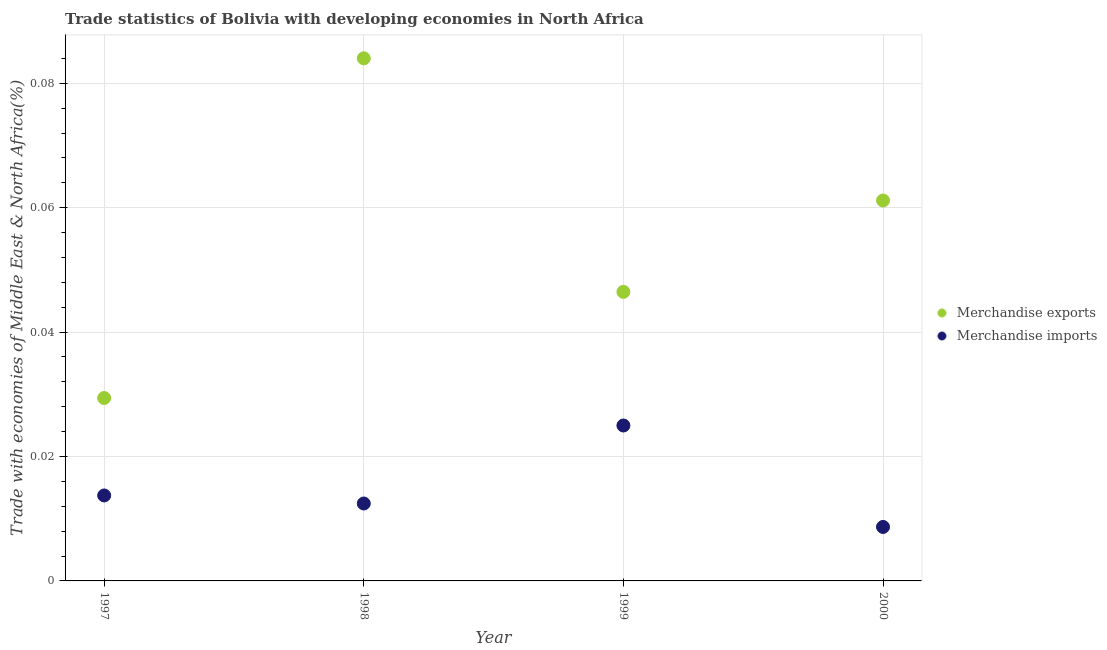How many different coloured dotlines are there?
Provide a succinct answer. 2. Is the number of dotlines equal to the number of legend labels?
Your answer should be very brief. Yes. What is the merchandise exports in 2000?
Ensure brevity in your answer.  0.06. Across all years, what is the maximum merchandise imports?
Your response must be concise. 0.02. Across all years, what is the minimum merchandise imports?
Your response must be concise. 0.01. What is the total merchandise exports in the graph?
Ensure brevity in your answer.  0.22. What is the difference between the merchandise imports in 1999 and that in 2000?
Your response must be concise. 0.02. What is the difference between the merchandise exports in 1997 and the merchandise imports in 2000?
Your answer should be compact. 0.02. What is the average merchandise exports per year?
Provide a short and direct response. 0.06. In the year 1997, what is the difference between the merchandise imports and merchandise exports?
Give a very brief answer. -0.02. What is the ratio of the merchandise exports in 1997 to that in 1998?
Provide a short and direct response. 0.35. Is the merchandise imports in 1997 less than that in 2000?
Give a very brief answer. No. What is the difference between the highest and the second highest merchandise exports?
Your response must be concise. 0.02. What is the difference between the highest and the lowest merchandise exports?
Provide a succinct answer. 0.05. In how many years, is the merchandise exports greater than the average merchandise exports taken over all years?
Make the answer very short. 2. Is the sum of the merchandise exports in 1999 and 2000 greater than the maximum merchandise imports across all years?
Your answer should be very brief. Yes. Is the merchandise exports strictly less than the merchandise imports over the years?
Ensure brevity in your answer.  No. How many dotlines are there?
Provide a short and direct response. 2. How many years are there in the graph?
Provide a short and direct response. 4. Are the values on the major ticks of Y-axis written in scientific E-notation?
Your answer should be very brief. No. Does the graph contain any zero values?
Your response must be concise. No. Does the graph contain grids?
Provide a short and direct response. Yes. Where does the legend appear in the graph?
Ensure brevity in your answer.  Center right. How many legend labels are there?
Provide a succinct answer. 2. How are the legend labels stacked?
Make the answer very short. Vertical. What is the title of the graph?
Provide a succinct answer. Trade statistics of Bolivia with developing economies in North Africa. Does "Research and Development" appear as one of the legend labels in the graph?
Make the answer very short. No. What is the label or title of the Y-axis?
Keep it short and to the point. Trade with economies of Middle East & North Africa(%). What is the Trade with economies of Middle East & North Africa(%) of Merchandise exports in 1997?
Provide a succinct answer. 0.03. What is the Trade with economies of Middle East & North Africa(%) in Merchandise imports in 1997?
Offer a very short reply. 0.01. What is the Trade with economies of Middle East & North Africa(%) of Merchandise exports in 1998?
Your response must be concise. 0.08. What is the Trade with economies of Middle East & North Africa(%) in Merchandise imports in 1998?
Ensure brevity in your answer.  0.01. What is the Trade with economies of Middle East & North Africa(%) in Merchandise exports in 1999?
Your answer should be very brief. 0.05. What is the Trade with economies of Middle East & North Africa(%) of Merchandise imports in 1999?
Keep it short and to the point. 0.02. What is the Trade with economies of Middle East & North Africa(%) in Merchandise exports in 2000?
Your answer should be compact. 0.06. What is the Trade with economies of Middle East & North Africa(%) of Merchandise imports in 2000?
Provide a short and direct response. 0.01. Across all years, what is the maximum Trade with economies of Middle East & North Africa(%) of Merchandise exports?
Make the answer very short. 0.08. Across all years, what is the maximum Trade with economies of Middle East & North Africa(%) in Merchandise imports?
Your response must be concise. 0.02. Across all years, what is the minimum Trade with economies of Middle East & North Africa(%) in Merchandise exports?
Your answer should be very brief. 0.03. Across all years, what is the minimum Trade with economies of Middle East & North Africa(%) of Merchandise imports?
Your response must be concise. 0.01. What is the total Trade with economies of Middle East & North Africa(%) in Merchandise exports in the graph?
Your response must be concise. 0.22. What is the total Trade with economies of Middle East & North Africa(%) in Merchandise imports in the graph?
Provide a short and direct response. 0.06. What is the difference between the Trade with economies of Middle East & North Africa(%) of Merchandise exports in 1997 and that in 1998?
Make the answer very short. -0.05. What is the difference between the Trade with economies of Middle East & North Africa(%) in Merchandise imports in 1997 and that in 1998?
Give a very brief answer. 0. What is the difference between the Trade with economies of Middle East & North Africa(%) in Merchandise exports in 1997 and that in 1999?
Offer a terse response. -0.02. What is the difference between the Trade with economies of Middle East & North Africa(%) of Merchandise imports in 1997 and that in 1999?
Your answer should be very brief. -0.01. What is the difference between the Trade with economies of Middle East & North Africa(%) of Merchandise exports in 1997 and that in 2000?
Your response must be concise. -0.03. What is the difference between the Trade with economies of Middle East & North Africa(%) in Merchandise imports in 1997 and that in 2000?
Provide a succinct answer. 0.01. What is the difference between the Trade with economies of Middle East & North Africa(%) of Merchandise exports in 1998 and that in 1999?
Your answer should be very brief. 0.04. What is the difference between the Trade with economies of Middle East & North Africa(%) of Merchandise imports in 1998 and that in 1999?
Make the answer very short. -0.01. What is the difference between the Trade with economies of Middle East & North Africa(%) of Merchandise exports in 1998 and that in 2000?
Offer a terse response. 0.02. What is the difference between the Trade with economies of Middle East & North Africa(%) in Merchandise imports in 1998 and that in 2000?
Ensure brevity in your answer.  0. What is the difference between the Trade with economies of Middle East & North Africa(%) of Merchandise exports in 1999 and that in 2000?
Provide a succinct answer. -0.01. What is the difference between the Trade with economies of Middle East & North Africa(%) in Merchandise imports in 1999 and that in 2000?
Provide a succinct answer. 0.02. What is the difference between the Trade with economies of Middle East & North Africa(%) in Merchandise exports in 1997 and the Trade with economies of Middle East & North Africa(%) in Merchandise imports in 1998?
Offer a very short reply. 0.02. What is the difference between the Trade with economies of Middle East & North Africa(%) in Merchandise exports in 1997 and the Trade with economies of Middle East & North Africa(%) in Merchandise imports in 1999?
Offer a very short reply. 0. What is the difference between the Trade with economies of Middle East & North Africa(%) in Merchandise exports in 1997 and the Trade with economies of Middle East & North Africa(%) in Merchandise imports in 2000?
Ensure brevity in your answer.  0.02. What is the difference between the Trade with economies of Middle East & North Africa(%) in Merchandise exports in 1998 and the Trade with economies of Middle East & North Africa(%) in Merchandise imports in 1999?
Your response must be concise. 0.06. What is the difference between the Trade with economies of Middle East & North Africa(%) of Merchandise exports in 1998 and the Trade with economies of Middle East & North Africa(%) of Merchandise imports in 2000?
Make the answer very short. 0.08. What is the difference between the Trade with economies of Middle East & North Africa(%) in Merchandise exports in 1999 and the Trade with economies of Middle East & North Africa(%) in Merchandise imports in 2000?
Give a very brief answer. 0.04. What is the average Trade with economies of Middle East & North Africa(%) in Merchandise exports per year?
Your answer should be very brief. 0.06. What is the average Trade with economies of Middle East & North Africa(%) in Merchandise imports per year?
Provide a short and direct response. 0.01. In the year 1997, what is the difference between the Trade with economies of Middle East & North Africa(%) of Merchandise exports and Trade with economies of Middle East & North Africa(%) of Merchandise imports?
Offer a very short reply. 0.02. In the year 1998, what is the difference between the Trade with economies of Middle East & North Africa(%) of Merchandise exports and Trade with economies of Middle East & North Africa(%) of Merchandise imports?
Make the answer very short. 0.07. In the year 1999, what is the difference between the Trade with economies of Middle East & North Africa(%) of Merchandise exports and Trade with economies of Middle East & North Africa(%) of Merchandise imports?
Offer a very short reply. 0.02. In the year 2000, what is the difference between the Trade with economies of Middle East & North Africa(%) in Merchandise exports and Trade with economies of Middle East & North Africa(%) in Merchandise imports?
Your answer should be very brief. 0.05. What is the ratio of the Trade with economies of Middle East & North Africa(%) of Merchandise imports in 1997 to that in 1998?
Your answer should be compact. 1.1. What is the ratio of the Trade with economies of Middle East & North Africa(%) of Merchandise exports in 1997 to that in 1999?
Provide a short and direct response. 0.63. What is the ratio of the Trade with economies of Middle East & North Africa(%) in Merchandise imports in 1997 to that in 1999?
Make the answer very short. 0.55. What is the ratio of the Trade with economies of Middle East & North Africa(%) in Merchandise exports in 1997 to that in 2000?
Provide a succinct answer. 0.48. What is the ratio of the Trade with economies of Middle East & North Africa(%) of Merchandise imports in 1997 to that in 2000?
Offer a terse response. 1.58. What is the ratio of the Trade with economies of Middle East & North Africa(%) in Merchandise exports in 1998 to that in 1999?
Your answer should be very brief. 1.81. What is the ratio of the Trade with economies of Middle East & North Africa(%) in Merchandise imports in 1998 to that in 1999?
Provide a short and direct response. 0.5. What is the ratio of the Trade with economies of Middle East & North Africa(%) of Merchandise exports in 1998 to that in 2000?
Offer a very short reply. 1.37. What is the ratio of the Trade with economies of Middle East & North Africa(%) of Merchandise imports in 1998 to that in 2000?
Ensure brevity in your answer.  1.43. What is the ratio of the Trade with economies of Middle East & North Africa(%) of Merchandise exports in 1999 to that in 2000?
Give a very brief answer. 0.76. What is the ratio of the Trade with economies of Middle East & North Africa(%) of Merchandise imports in 1999 to that in 2000?
Your answer should be very brief. 2.88. What is the difference between the highest and the second highest Trade with economies of Middle East & North Africa(%) in Merchandise exports?
Make the answer very short. 0.02. What is the difference between the highest and the second highest Trade with economies of Middle East & North Africa(%) of Merchandise imports?
Your answer should be very brief. 0.01. What is the difference between the highest and the lowest Trade with economies of Middle East & North Africa(%) of Merchandise exports?
Ensure brevity in your answer.  0.05. What is the difference between the highest and the lowest Trade with economies of Middle East & North Africa(%) of Merchandise imports?
Your answer should be compact. 0.02. 